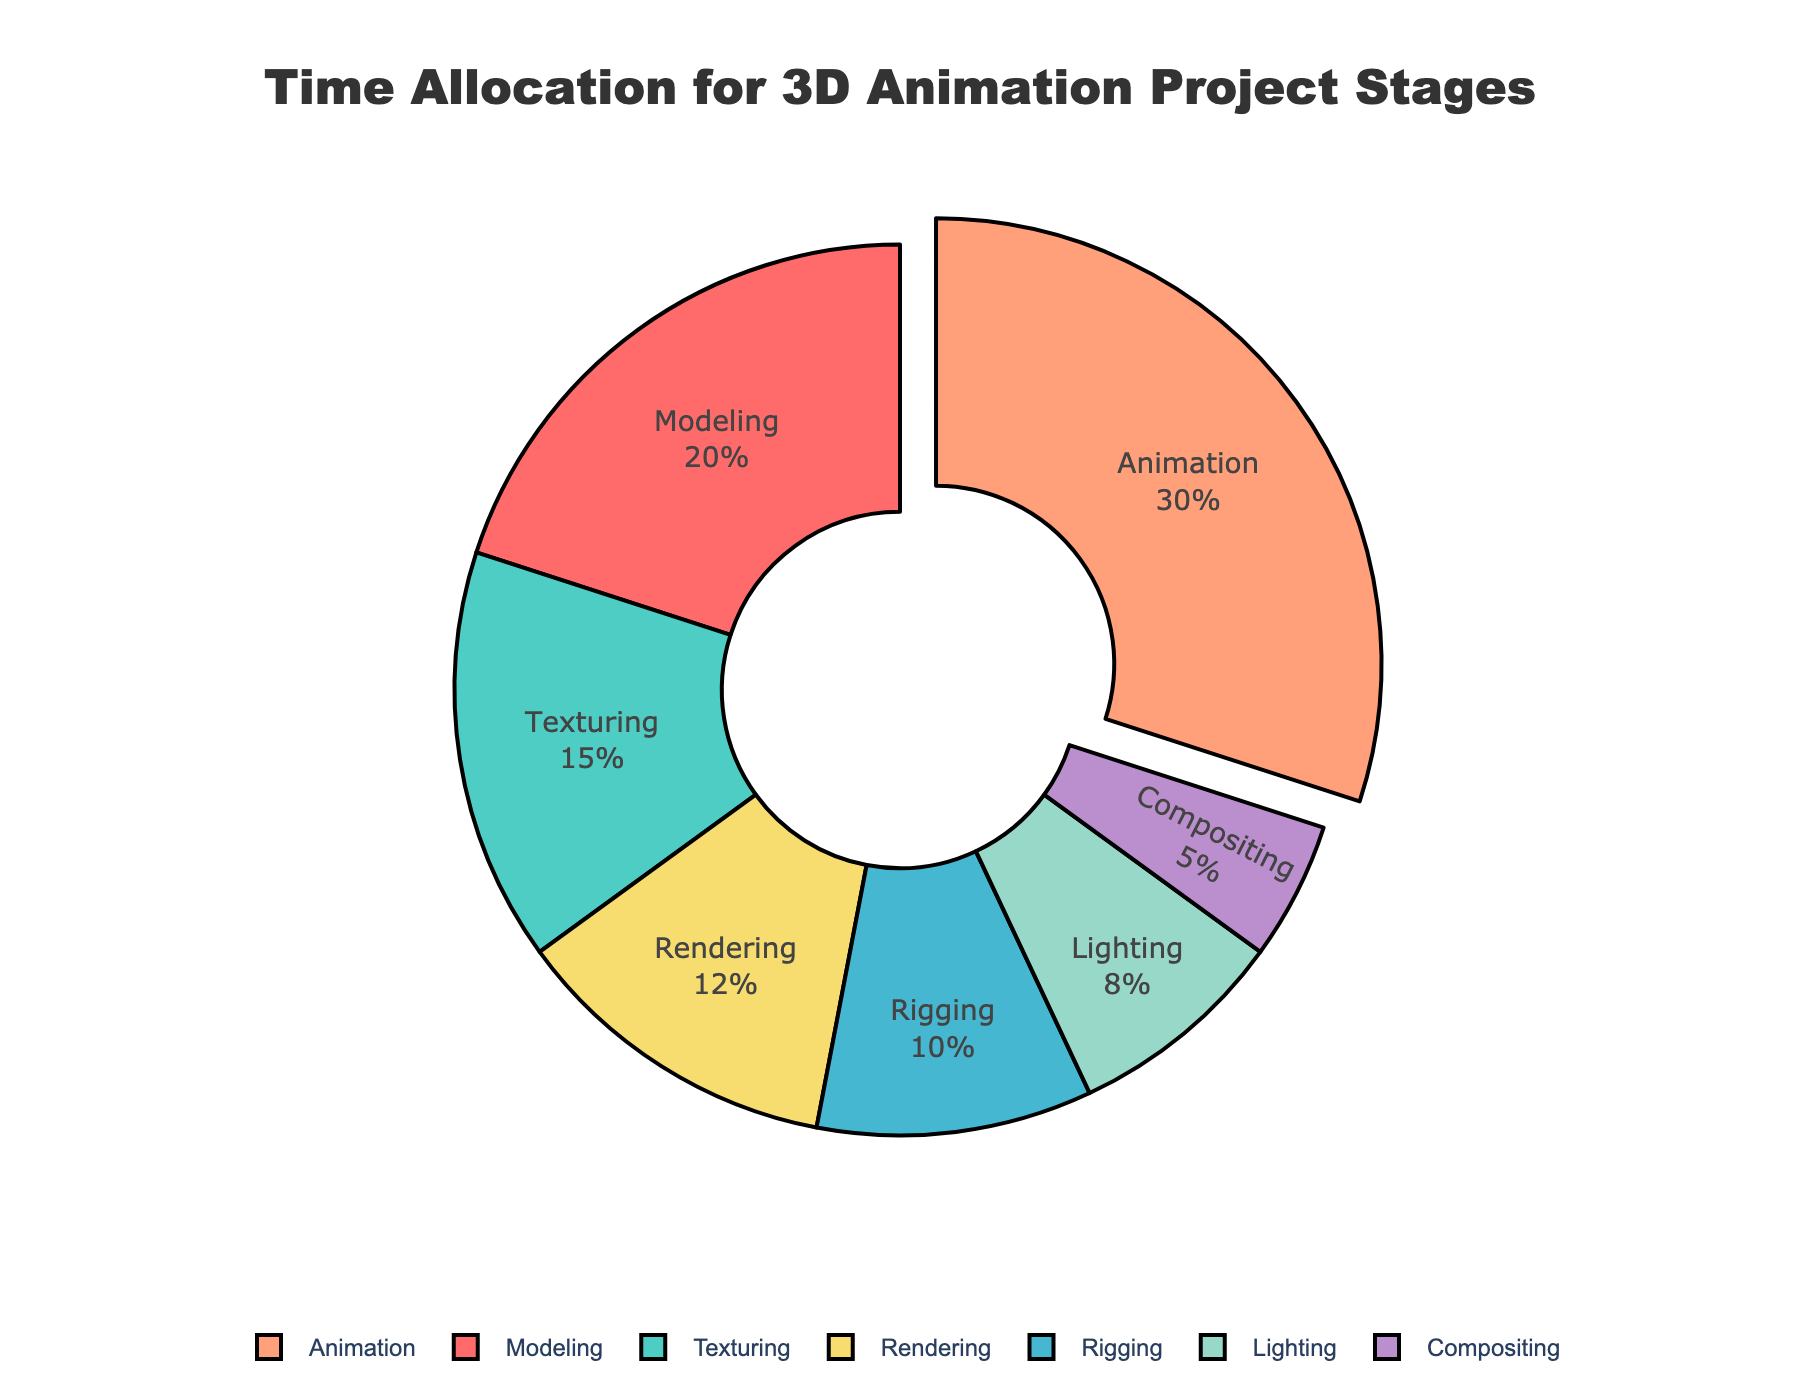What stage takes up the highest percentage of time in a 3D animation project? The slice with the largest percentage and the one that's slightly pulled out indicates the stage with the highest time allocation. This slice is the "Animation" stage with 30%.
Answer: Animation What is the combined percentage of time spent on Modeling and Texturing? Look at the percentages for "Modeling" and "Texturing" and add them together. "Modeling" is 20% and "Texturing" is 15%, so 20% + 15% = 35%.
Answer: 35% Which stages together account for less than 10% of the time each? Look for slices that represent less than 10%. The stages "Lighting" (8%) and "Compositing" (5%) both account for less than 10%.
Answer: Lighting and Compositing How much more time is allocated to Rigging compared to Compositing? Identify the percentages for "Rigging" and "Compositing", then subtract the percentage of "Compositing" from "Rigging". Rigging is 10% and Compositing is 5%, so 10% - 5% = 5%.
Answer: 5% What are the colors used to represent the "Rendering" and "Lighting" stages? The slice for "Rendering" is represented in a medium yellow color, and "Lighting" is in a light yellow-green color in the chart.
Answer: Medium yellow for Rendering, light yellow-green for Lighting Rank the stages from highest to lowest in terms of time allocation. Read the slices from the largest to the smallest to determine the ranking. "Animation" (30%), "Modeling" (20%), "Texturing" (15%), "Rendering" (12%), "Rigging" (10%), "Lighting" (8%), "Compositing" (5%).
Answer: Animation, Modeling, Texturing, Rendering, Rigging, Lighting, Compositing What is the average percentage time spent on the stages other than Animation? Sum the percentages of all stages except "Animation" and divide by the number of these stages. (20% + 15% + 10% + 8% + 12% + 5%) = 70%, there are 6 stages, so 70% / 6 ≈ 11.67%.
Answer: 11.67% 